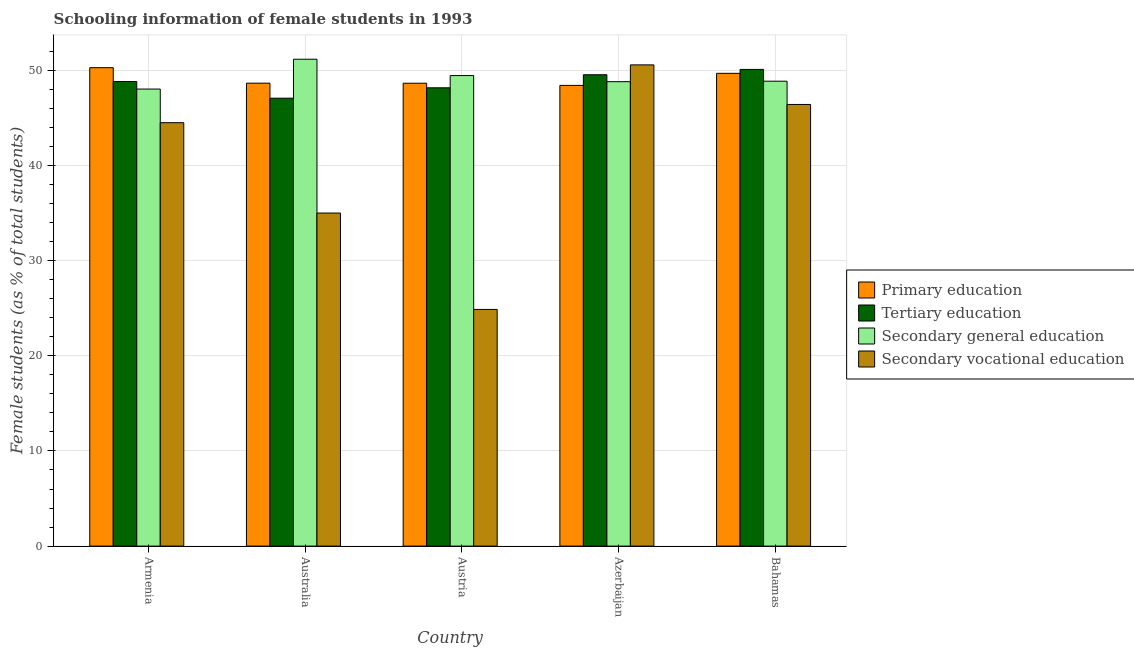How many different coloured bars are there?
Provide a short and direct response. 4. How many bars are there on the 1st tick from the left?
Provide a short and direct response. 4. What is the label of the 2nd group of bars from the left?
Provide a short and direct response. Australia. What is the percentage of female students in secondary education in Bahamas?
Keep it short and to the point. 48.86. Across all countries, what is the maximum percentage of female students in tertiary education?
Your answer should be compact. 50.09. Across all countries, what is the minimum percentage of female students in secondary vocational education?
Your answer should be very brief. 24.87. In which country was the percentage of female students in tertiary education maximum?
Your answer should be compact. Bahamas. In which country was the percentage of female students in tertiary education minimum?
Provide a succinct answer. Australia. What is the total percentage of female students in primary education in the graph?
Give a very brief answer. 245.66. What is the difference between the percentage of female students in secondary vocational education in Australia and that in Bahamas?
Make the answer very short. -11.41. What is the difference between the percentage of female students in primary education in Azerbaijan and the percentage of female students in secondary education in Armenia?
Keep it short and to the point. 0.39. What is the average percentage of female students in secondary vocational education per country?
Provide a succinct answer. 40.27. What is the difference between the percentage of female students in primary education and percentage of female students in tertiary education in Armenia?
Ensure brevity in your answer.  1.45. What is the ratio of the percentage of female students in secondary vocational education in Azerbaijan to that in Bahamas?
Offer a terse response. 1.09. Is the percentage of female students in secondary education in Armenia less than that in Azerbaijan?
Offer a very short reply. Yes. What is the difference between the highest and the second highest percentage of female students in tertiary education?
Your answer should be very brief. 0.56. What is the difference between the highest and the lowest percentage of female students in tertiary education?
Provide a short and direct response. 3.02. In how many countries, is the percentage of female students in secondary education greater than the average percentage of female students in secondary education taken over all countries?
Offer a terse response. 2. What does the 1st bar from the left in Armenia represents?
Provide a short and direct response. Primary education. What is the difference between two consecutive major ticks on the Y-axis?
Provide a short and direct response. 10. Does the graph contain any zero values?
Keep it short and to the point. No. Where does the legend appear in the graph?
Provide a succinct answer. Center right. How many legend labels are there?
Ensure brevity in your answer.  4. What is the title of the graph?
Your answer should be compact. Schooling information of female students in 1993. What is the label or title of the Y-axis?
Give a very brief answer. Female students (as % of total students). What is the Female students (as % of total students) in Primary education in Armenia?
Provide a succinct answer. 50.28. What is the Female students (as % of total students) of Tertiary education in Armenia?
Give a very brief answer. 48.82. What is the Female students (as % of total students) of Secondary general education in Armenia?
Make the answer very short. 48.03. What is the Female students (as % of total students) of Secondary vocational education in Armenia?
Your answer should be compact. 44.49. What is the Female students (as % of total students) in Primary education in Australia?
Provide a short and direct response. 48.65. What is the Female students (as % of total students) of Tertiary education in Australia?
Offer a very short reply. 47.07. What is the Female students (as % of total students) of Secondary general education in Australia?
Provide a short and direct response. 51.16. What is the Female students (as % of total students) of Secondary vocational education in Australia?
Ensure brevity in your answer.  35. What is the Female students (as % of total students) of Primary education in Austria?
Offer a terse response. 48.64. What is the Female students (as % of total students) of Tertiary education in Austria?
Give a very brief answer. 48.16. What is the Female students (as % of total students) of Secondary general education in Austria?
Provide a short and direct response. 49.45. What is the Female students (as % of total students) in Secondary vocational education in Austria?
Make the answer very short. 24.87. What is the Female students (as % of total students) in Primary education in Azerbaijan?
Give a very brief answer. 48.42. What is the Female students (as % of total students) in Tertiary education in Azerbaijan?
Provide a succinct answer. 49.53. What is the Female students (as % of total students) in Secondary general education in Azerbaijan?
Your response must be concise. 48.8. What is the Female students (as % of total students) in Secondary vocational education in Azerbaijan?
Make the answer very short. 50.57. What is the Female students (as % of total students) in Primary education in Bahamas?
Provide a succinct answer. 49.68. What is the Female students (as % of total students) of Tertiary education in Bahamas?
Provide a succinct answer. 50.09. What is the Female students (as % of total students) of Secondary general education in Bahamas?
Ensure brevity in your answer.  48.86. What is the Female students (as % of total students) in Secondary vocational education in Bahamas?
Ensure brevity in your answer.  46.41. Across all countries, what is the maximum Female students (as % of total students) in Primary education?
Keep it short and to the point. 50.28. Across all countries, what is the maximum Female students (as % of total students) of Tertiary education?
Keep it short and to the point. 50.09. Across all countries, what is the maximum Female students (as % of total students) in Secondary general education?
Your response must be concise. 51.16. Across all countries, what is the maximum Female students (as % of total students) of Secondary vocational education?
Ensure brevity in your answer.  50.57. Across all countries, what is the minimum Female students (as % of total students) in Primary education?
Provide a short and direct response. 48.42. Across all countries, what is the minimum Female students (as % of total students) in Tertiary education?
Your answer should be very brief. 47.07. Across all countries, what is the minimum Female students (as % of total students) of Secondary general education?
Keep it short and to the point. 48.03. Across all countries, what is the minimum Female students (as % of total students) in Secondary vocational education?
Ensure brevity in your answer.  24.87. What is the total Female students (as % of total students) of Primary education in the graph?
Ensure brevity in your answer.  245.66. What is the total Female students (as % of total students) of Tertiary education in the graph?
Offer a terse response. 243.68. What is the total Female students (as % of total students) of Secondary general education in the graph?
Ensure brevity in your answer.  246.3. What is the total Female students (as % of total students) in Secondary vocational education in the graph?
Offer a very short reply. 201.34. What is the difference between the Female students (as % of total students) in Primary education in Armenia and that in Australia?
Make the answer very short. 1.63. What is the difference between the Female students (as % of total students) in Tertiary education in Armenia and that in Australia?
Give a very brief answer. 1.75. What is the difference between the Female students (as % of total students) of Secondary general education in Armenia and that in Australia?
Give a very brief answer. -3.14. What is the difference between the Female students (as % of total students) in Secondary vocational education in Armenia and that in Australia?
Make the answer very short. 9.49. What is the difference between the Female students (as % of total students) of Primary education in Armenia and that in Austria?
Your answer should be compact. 1.63. What is the difference between the Female students (as % of total students) in Tertiary education in Armenia and that in Austria?
Ensure brevity in your answer.  0.66. What is the difference between the Female students (as % of total students) of Secondary general education in Armenia and that in Austria?
Provide a succinct answer. -1.42. What is the difference between the Female students (as % of total students) of Secondary vocational education in Armenia and that in Austria?
Your answer should be very brief. 19.62. What is the difference between the Female students (as % of total students) of Primary education in Armenia and that in Azerbaijan?
Ensure brevity in your answer.  1.86. What is the difference between the Female students (as % of total students) of Tertiary education in Armenia and that in Azerbaijan?
Provide a succinct answer. -0.71. What is the difference between the Female students (as % of total students) of Secondary general education in Armenia and that in Azerbaijan?
Keep it short and to the point. -0.78. What is the difference between the Female students (as % of total students) of Secondary vocational education in Armenia and that in Azerbaijan?
Offer a terse response. -6.08. What is the difference between the Female students (as % of total students) in Primary education in Armenia and that in Bahamas?
Your answer should be compact. 0.6. What is the difference between the Female students (as % of total students) in Tertiary education in Armenia and that in Bahamas?
Provide a short and direct response. -1.27. What is the difference between the Female students (as % of total students) of Secondary general education in Armenia and that in Bahamas?
Give a very brief answer. -0.83. What is the difference between the Female students (as % of total students) in Secondary vocational education in Armenia and that in Bahamas?
Your response must be concise. -1.92. What is the difference between the Female students (as % of total students) of Primary education in Australia and that in Austria?
Your response must be concise. 0.01. What is the difference between the Female students (as % of total students) in Tertiary education in Australia and that in Austria?
Give a very brief answer. -1.09. What is the difference between the Female students (as % of total students) of Secondary general education in Australia and that in Austria?
Give a very brief answer. 1.72. What is the difference between the Female students (as % of total students) in Secondary vocational education in Australia and that in Austria?
Make the answer very short. 10.13. What is the difference between the Female students (as % of total students) in Primary education in Australia and that in Azerbaijan?
Offer a very short reply. 0.23. What is the difference between the Female students (as % of total students) of Tertiary education in Australia and that in Azerbaijan?
Offer a very short reply. -2.46. What is the difference between the Female students (as % of total students) in Secondary general education in Australia and that in Azerbaijan?
Keep it short and to the point. 2.36. What is the difference between the Female students (as % of total students) in Secondary vocational education in Australia and that in Azerbaijan?
Offer a terse response. -15.57. What is the difference between the Female students (as % of total students) in Primary education in Australia and that in Bahamas?
Offer a terse response. -1.03. What is the difference between the Female students (as % of total students) in Tertiary education in Australia and that in Bahamas?
Make the answer very short. -3.02. What is the difference between the Female students (as % of total students) of Secondary general education in Australia and that in Bahamas?
Offer a terse response. 2.31. What is the difference between the Female students (as % of total students) of Secondary vocational education in Australia and that in Bahamas?
Offer a terse response. -11.41. What is the difference between the Female students (as % of total students) of Primary education in Austria and that in Azerbaijan?
Your answer should be very brief. 0.23. What is the difference between the Female students (as % of total students) in Tertiary education in Austria and that in Azerbaijan?
Keep it short and to the point. -1.37. What is the difference between the Female students (as % of total students) of Secondary general education in Austria and that in Azerbaijan?
Offer a very short reply. 0.64. What is the difference between the Female students (as % of total students) in Secondary vocational education in Austria and that in Azerbaijan?
Your response must be concise. -25.7. What is the difference between the Female students (as % of total students) in Primary education in Austria and that in Bahamas?
Keep it short and to the point. -1.04. What is the difference between the Female students (as % of total students) in Tertiary education in Austria and that in Bahamas?
Your answer should be compact. -1.93. What is the difference between the Female students (as % of total students) of Secondary general education in Austria and that in Bahamas?
Offer a very short reply. 0.59. What is the difference between the Female students (as % of total students) of Secondary vocational education in Austria and that in Bahamas?
Ensure brevity in your answer.  -21.54. What is the difference between the Female students (as % of total students) in Primary education in Azerbaijan and that in Bahamas?
Your response must be concise. -1.26. What is the difference between the Female students (as % of total students) of Tertiary education in Azerbaijan and that in Bahamas?
Provide a short and direct response. -0.56. What is the difference between the Female students (as % of total students) of Secondary general education in Azerbaijan and that in Bahamas?
Make the answer very short. -0.05. What is the difference between the Female students (as % of total students) in Secondary vocational education in Azerbaijan and that in Bahamas?
Offer a terse response. 4.16. What is the difference between the Female students (as % of total students) in Primary education in Armenia and the Female students (as % of total students) in Tertiary education in Australia?
Keep it short and to the point. 3.21. What is the difference between the Female students (as % of total students) of Primary education in Armenia and the Female students (as % of total students) of Secondary general education in Australia?
Offer a very short reply. -0.89. What is the difference between the Female students (as % of total students) in Primary education in Armenia and the Female students (as % of total students) in Secondary vocational education in Australia?
Provide a short and direct response. 15.28. What is the difference between the Female students (as % of total students) of Tertiary education in Armenia and the Female students (as % of total students) of Secondary general education in Australia?
Keep it short and to the point. -2.34. What is the difference between the Female students (as % of total students) in Tertiary education in Armenia and the Female students (as % of total students) in Secondary vocational education in Australia?
Your answer should be compact. 13.82. What is the difference between the Female students (as % of total students) in Secondary general education in Armenia and the Female students (as % of total students) in Secondary vocational education in Australia?
Your answer should be very brief. 13.03. What is the difference between the Female students (as % of total students) of Primary education in Armenia and the Female students (as % of total students) of Tertiary education in Austria?
Offer a terse response. 2.11. What is the difference between the Female students (as % of total students) of Primary education in Armenia and the Female students (as % of total students) of Secondary general education in Austria?
Your answer should be very brief. 0.83. What is the difference between the Female students (as % of total students) of Primary education in Armenia and the Female students (as % of total students) of Secondary vocational education in Austria?
Offer a very short reply. 25.4. What is the difference between the Female students (as % of total students) in Tertiary education in Armenia and the Female students (as % of total students) in Secondary general education in Austria?
Offer a very short reply. -0.63. What is the difference between the Female students (as % of total students) in Tertiary education in Armenia and the Female students (as % of total students) in Secondary vocational education in Austria?
Offer a terse response. 23.95. What is the difference between the Female students (as % of total students) in Secondary general education in Armenia and the Female students (as % of total students) in Secondary vocational education in Austria?
Provide a succinct answer. 23.16. What is the difference between the Female students (as % of total students) of Primary education in Armenia and the Female students (as % of total students) of Tertiary education in Azerbaijan?
Ensure brevity in your answer.  0.74. What is the difference between the Female students (as % of total students) of Primary education in Armenia and the Female students (as % of total students) of Secondary general education in Azerbaijan?
Make the answer very short. 1.47. What is the difference between the Female students (as % of total students) in Primary education in Armenia and the Female students (as % of total students) in Secondary vocational education in Azerbaijan?
Provide a succinct answer. -0.29. What is the difference between the Female students (as % of total students) in Tertiary education in Armenia and the Female students (as % of total students) in Secondary general education in Azerbaijan?
Provide a succinct answer. 0.02. What is the difference between the Female students (as % of total students) in Tertiary education in Armenia and the Female students (as % of total students) in Secondary vocational education in Azerbaijan?
Provide a short and direct response. -1.75. What is the difference between the Female students (as % of total students) of Secondary general education in Armenia and the Female students (as % of total students) of Secondary vocational education in Azerbaijan?
Provide a short and direct response. -2.54. What is the difference between the Female students (as % of total students) of Primary education in Armenia and the Female students (as % of total students) of Tertiary education in Bahamas?
Keep it short and to the point. 0.18. What is the difference between the Female students (as % of total students) of Primary education in Armenia and the Female students (as % of total students) of Secondary general education in Bahamas?
Offer a terse response. 1.42. What is the difference between the Female students (as % of total students) in Primary education in Armenia and the Female students (as % of total students) in Secondary vocational education in Bahamas?
Your response must be concise. 3.87. What is the difference between the Female students (as % of total students) in Tertiary education in Armenia and the Female students (as % of total students) in Secondary general education in Bahamas?
Your answer should be very brief. -0.03. What is the difference between the Female students (as % of total students) of Tertiary education in Armenia and the Female students (as % of total students) of Secondary vocational education in Bahamas?
Your response must be concise. 2.41. What is the difference between the Female students (as % of total students) of Secondary general education in Armenia and the Female students (as % of total students) of Secondary vocational education in Bahamas?
Your answer should be very brief. 1.62. What is the difference between the Female students (as % of total students) of Primary education in Australia and the Female students (as % of total students) of Tertiary education in Austria?
Provide a succinct answer. 0.49. What is the difference between the Female students (as % of total students) in Primary education in Australia and the Female students (as % of total students) in Secondary general education in Austria?
Your answer should be compact. -0.8. What is the difference between the Female students (as % of total students) in Primary education in Australia and the Female students (as % of total students) in Secondary vocational education in Austria?
Ensure brevity in your answer.  23.78. What is the difference between the Female students (as % of total students) in Tertiary education in Australia and the Female students (as % of total students) in Secondary general education in Austria?
Offer a very short reply. -2.38. What is the difference between the Female students (as % of total students) of Tertiary education in Australia and the Female students (as % of total students) of Secondary vocational education in Austria?
Offer a very short reply. 22.2. What is the difference between the Female students (as % of total students) of Secondary general education in Australia and the Female students (as % of total students) of Secondary vocational education in Austria?
Keep it short and to the point. 26.29. What is the difference between the Female students (as % of total students) of Primary education in Australia and the Female students (as % of total students) of Tertiary education in Azerbaijan?
Your response must be concise. -0.89. What is the difference between the Female students (as % of total students) in Primary education in Australia and the Female students (as % of total students) in Secondary general education in Azerbaijan?
Your answer should be compact. -0.16. What is the difference between the Female students (as % of total students) of Primary education in Australia and the Female students (as % of total students) of Secondary vocational education in Azerbaijan?
Make the answer very short. -1.92. What is the difference between the Female students (as % of total students) of Tertiary education in Australia and the Female students (as % of total students) of Secondary general education in Azerbaijan?
Ensure brevity in your answer.  -1.73. What is the difference between the Female students (as % of total students) in Tertiary education in Australia and the Female students (as % of total students) in Secondary vocational education in Azerbaijan?
Keep it short and to the point. -3.5. What is the difference between the Female students (as % of total students) in Secondary general education in Australia and the Female students (as % of total students) in Secondary vocational education in Azerbaijan?
Keep it short and to the point. 0.6. What is the difference between the Female students (as % of total students) in Primary education in Australia and the Female students (as % of total students) in Tertiary education in Bahamas?
Your answer should be compact. -1.44. What is the difference between the Female students (as % of total students) of Primary education in Australia and the Female students (as % of total students) of Secondary general education in Bahamas?
Your response must be concise. -0.21. What is the difference between the Female students (as % of total students) in Primary education in Australia and the Female students (as % of total students) in Secondary vocational education in Bahamas?
Ensure brevity in your answer.  2.24. What is the difference between the Female students (as % of total students) in Tertiary education in Australia and the Female students (as % of total students) in Secondary general education in Bahamas?
Your response must be concise. -1.79. What is the difference between the Female students (as % of total students) in Tertiary education in Australia and the Female students (as % of total students) in Secondary vocational education in Bahamas?
Your answer should be very brief. 0.66. What is the difference between the Female students (as % of total students) of Secondary general education in Australia and the Female students (as % of total students) of Secondary vocational education in Bahamas?
Offer a terse response. 4.76. What is the difference between the Female students (as % of total students) in Primary education in Austria and the Female students (as % of total students) in Tertiary education in Azerbaijan?
Your answer should be very brief. -0.89. What is the difference between the Female students (as % of total students) in Primary education in Austria and the Female students (as % of total students) in Secondary general education in Azerbaijan?
Your answer should be very brief. -0.16. What is the difference between the Female students (as % of total students) of Primary education in Austria and the Female students (as % of total students) of Secondary vocational education in Azerbaijan?
Ensure brevity in your answer.  -1.93. What is the difference between the Female students (as % of total students) of Tertiary education in Austria and the Female students (as % of total students) of Secondary general education in Azerbaijan?
Make the answer very short. -0.64. What is the difference between the Female students (as % of total students) in Tertiary education in Austria and the Female students (as % of total students) in Secondary vocational education in Azerbaijan?
Your answer should be compact. -2.41. What is the difference between the Female students (as % of total students) of Secondary general education in Austria and the Female students (as % of total students) of Secondary vocational education in Azerbaijan?
Keep it short and to the point. -1.12. What is the difference between the Female students (as % of total students) of Primary education in Austria and the Female students (as % of total students) of Tertiary education in Bahamas?
Your response must be concise. -1.45. What is the difference between the Female students (as % of total students) of Primary education in Austria and the Female students (as % of total students) of Secondary general education in Bahamas?
Offer a very short reply. -0.21. What is the difference between the Female students (as % of total students) of Primary education in Austria and the Female students (as % of total students) of Secondary vocational education in Bahamas?
Make the answer very short. 2.23. What is the difference between the Female students (as % of total students) of Tertiary education in Austria and the Female students (as % of total students) of Secondary general education in Bahamas?
Ensure brevity in your answer.  -0.69. What is the difference between the Female students (as % of total students) in Tertiary education in Austria and the Female students (as % of total students) in Secondary vocational education in Bahamas?
Provide a short and direct response. 1.75. What is the difference between the Female students (as % of total students) of Secondary general education in Austria and the Female students (as % of total students) of Secondary vocational education in Bahamas?
Ensure brevity in your answer.  3.04. What is the difference between the Female students (as % of total students) of Primary education in Azerbaijan and the Female students (as % of total students) of Tertiary education in Bahamas?
Give a very brief answer. -1.68. What is the difference between the Female students (as % of total students) of Primary education in Azerbaijan and the Female students (as % of total students) of Secondary general education in Bahamas?
Make the answer very short. -0.44. What is the difference between the Female students (as % of total students) of Primary education in Azerbaijan and the Female students (as % of total students) of Secondary vocational education in Bahamas?
Give a very brief answer. 2.01. What is the difference between the Female students (as % of total students) of Tertiary education in Azerbaijan and the Female students (as % of total students) of Secondary general education in Bahamas?
Your response must be concise. 0.68. What is the difference between the Female students (as % of total students) in Tertiary education in Azerbaijan and the Female students (as % of total students) in Secondary vocational education in Bahamas?
Give a very brief answer. 3.12. What is the difference between the Female students (as % of total students) in Secondary general education in Azerbaijan and the Female students (as % of total students) in Secondary vocational education in Bahamas?
Your answer should be compact. 2.39. What is the average Female students (as % of total students) in Primary education per country?
Your answer should be compact. 49.13. What is the average Female students (as % of total students) in Tertiary education per country?
Your response must be concise. 48.74. What is the average Female students (as % of total students) in Secondary general education per country?
Your response must be concise. 49.26. What is the average Female students (as % of total students) in Secondary vocational education per country?
Your answer should be very brief. 40.27. What is the difference between the Female students (as % of total students) in Primary education and Female students (as % of total students) in Tertiary education in Armenia?
Your answer should be compact. 1.45. What is the difference between the Female students (as % of total students) in Primary education and Female students (as % of total students) in Secondary general education in Armenia?
Keep it short and to the point. 2.25. What is the difference between the Female students (as % of total students) of Primary education and Female students (as % of total students) of Secondary vocational education in Armenia?
Your response must be concise. 5.78. What is the difference between the Female students (as % of total students) in Tertiary education and Female students (as % of total students) in Secondary general education in Armenia?
Provide a short and direct response. 0.79. What is the difference between the Female students (as % of total students) of Tertiary education and Female students (as % of total students) of Secondary vocational education in Armenia?
Your answer should be compact. 4.33. What is the difference between the Female students (as % of total students) in Secondary general education and Female students (as % of total students) in Secondary vocational education in Armenia?
Offer a terse response. 3.54. What is the difference between the Female students (as % of total students) in Primary education and Female students (as % of total students) in Tertiary education in Australia?
Offer a terse response. 1.58. What is the difference between the Female students (as % of total students) of Primary education and Female students (as % of total students) of Secondary general education in Australia?
Your response must be concise. -2.52. What is the difference between the Female students (as % of total students) of Primary education and Female students (as % of total students) of Secondary vocational education in Australia?
Your response must be concise. 13.65. What is the difference between the Female students (as % of total students) in Tertiary education and Female students (as % of total students) in Secondary general education in Australia?
Make the answer very short. -4.1. What is the difference between the Female students (as % of total students) of Tertiary education and Female students (as % of total students) of Secondary vocational education in Australia?
Your answer should be compact. 12.07. What is the difference between the Female students (as % of total students) in Secondary general education and Female students (as % of total students) in Secondary vocational education in Australia?
Your answer should be compact. 16.16. What is the difference between the Female students (as % of total students) of Primary education and Female students (as % of total students) of Tertiary education in Austria?
Give a very brief answer. 0.48. What is the difference between the Female students (as % of total students) in Primary education and Female students (as % of total students) in Secondary general education in Austria?
Your answer should be compact. -0.81. What is the difference between the Female students (as % of total students) of Primary education and Female students (as % of total students) of Secondary vocational education in Austria?
Provide a succinct answer. 23.77. What is the difference between the Female students (as % of total students) in Tertiary education and Female students (as % of total students) in Secondary general education in Austria?
Your response must be concise. -1.29. What is the difference between the Female students (as % of total students) in Tertiary education and Female students (as % of total students) in Secondary vocational education in Austria?
Provide a succinct answer. 23.29. What is the difference between the Female students (as % of total students) of Secondary general education and Female students (as % of total students) of Secondary vocational education in Austria?
Ensure brevity in your answer.  24.58. What is the difference between the Female students (as % of total students) of Primary education and Female students (as % of total students) of Tertiary education in Azerbaijan?
Provide a short and direct response. -1.12. What is the difference between the Female students (as % of total students) in Primary education and Female students (as % of total students) in Secondary general education in Azerbaijan?
Offer a terse response. -0.39. What is the difference between the Female students (as % of total students) in Primary education and Female students (as % of total students) in Secondary vocational education in Azerbaijan?
Make the answer very short. -2.15. What is the difference between the Female students (as % of total students) in Tertiary education and Female students (as % of total students) in Secondary general education in Azerbaijan?
Make the answer very short. 0.73. What is the difference between the Female students (as % of total students) of Tertiary education and Female students (as % of total students) of Secondary vocational education in Azerbaijan?
Ensure brevity in your answer.  -1.04. What is the difference between the Female students (as % of total students) of Secondary general education and Female students (as % of total students) of Secondary vocational education in Azerbaijan?
Keep it short and to the point. -1.77. What is the difference between the Female students (as % of total students) of Primary education and Female students (as % of total students) of Tertiary education in Bahamas?
Keep it short and to the point. -0.41. What is the difference between the Female students (as % of total students) of Primary education and Female students (as % of total students) of Secondary general education in Bahamas?
Your answer should be compact. 0.82. What is the difference between the Female students (as % of total students) in Primary education and Female students (as % of total students) in Secondary vocational education in Bahamas?
Keep it short and to the point. 3.27. What is the difference between the Female students (as % of total students) of Tertiary education and Female students (as % of total students) of Secondary general education in Bahamas?
Make the answer very short. 1.24. What is the difference between the Female students (as % of total students) of Tertiary education and Female students (as % of total students) of Secondary vocational education in Bahamas?
Ensure brevity in your answer.  3.68. What is the difference between the Female students (as % of total students) of Secondary general education and Female students (as % of total students) of Secondary vocational education in Bahamas?
Ensure brevity in your answer.  2.45. What is the ratio of the Female students (as % of total students) of Primary education in Armenia to that in Australia?
Give a very brief answer. 1.03. What is the ratio of the Female students (as % of total students) of Tertiary education in Armenia to that in Australia?
Your answer should be very brief. 1.04. What is the ratio of the Female students (as % of total students) of Secondary general education in Armenia to that in Australia?
Provide a succinct answer. 0.94. What is the ratio of the Female students (as % of total students) of Secondary vocational education in Armenia to that in Australia?
Your response must be concise. 1.27. What is the ratio of the Female students (as % of total students) of Primary education in Armenia to that in Austria?
Your answer should be very brief. 1.03. What is the ratio of the Female students (as % of total students) of Tertiary education in Armenia to that in Austria?
Offer a terse response. 1.01. What is the ratio of the Female students (as % of total students) of Secondary general education in Armenia to that in Austria?
Your answer should be compact. 0.97. What is the ratio of the Female students (as % of total students) of Secondary vocational education in Armenia to that in Austria?
Provide a short and direct response. 1.79. What is the ratio of the Female students (as % of total students) of Primary education in Armenia to that in Azerbaijan?
Give a very brief answer. 1.04. What is the ratio of the Female students (as % of total students) of Tertiary education in Armenia to that in Azerbaijan?
Your response must be concise. 0.99. What is the ratio of the Female students (as % of total students) in Secondary general education in Armenia to that in Azerbaijan?
Your answer should be very brief. 0.98. What is the ratio of the Female students (as % of total students) in Secondary vocational education in Armenia to that in Azerbaijan?
Your response must be concise. 0.88. What is the ratio of the Female students (as % of total students) of Tertiary education in Armenia to that in Bahamas?
Offer a terse response. 0.97. What is the ratio of the Female students (as % of total students) in Secondary general education in Armenia to that in Bahamas?
Make the answer very short. 0.98. What is the ratio of the Female students (as % of total students) of Secondary vocational education in Armenia to that in Bahamas?
Provide a short and direct response. 0.96. What is the ratio of the Female students (as % of total students) of Tertiary education in Australia to that in Austria?
Give a very brief answer. 0.98. What is the ratio of the Female students (as % of total students) of Secondary general education in Australia to that in Austria?
Provide a short and direct response. 1.03. What is the ratio of the Female students (as % of total students) in Secondary vocational education in Australia to that in Austria?
Provide a succinct answer. 1.41. What is the ratio of the Female students (as % of total students) of Tertiary education in Australia to that in Azerbaijan?
Provide a short and direct response. 0.95. What is the ratio of the Female students (as % of total students) in Secondary general education in Australia to that in Azerbaijan?
Give a very brief answer. 1.05. What is the ratio of the Female students (as % of total students) in Secondary vocational education in Australia to that in Azerbaijan?
Make the answer very short. 0.69. What is the ratio of the Female students (as % of total students) in Primary education in Australia to that in Bahamas?
Make the answer very short. 0.98. What is the ratio of the Female students (as % of total students) of Tertiary education in Australia to that in Bahamas?
Give a very brief answer. 0.94. What is the ratio of the Female students (as % of total students) of Secondary general education in Australia to that in Bahamas?
Provide a succinct answer. 1.05. What is the ratio of the Female students (as % of total students) in Secondary vocational education in Australia to that in Bahamas?
Offer a terse response. 0.75. What is the ratio of the Female students (as % of total students) of Primary education in Austria to that in Azerbaijan?
Your response must be concise. 1. What is the ratio of the Female students (as % of total students) in Tertiary education in Austria to that in Azerbaijan?
Your answer should be very brief. 0.97. What is the ratio of the Female students (as % of total students) in Secondary general education in Austria to that in Azerbaijan?
Keep it short and to the point. 1.01. What is the ratio of the Female students (as % of total students) of Secondary vocational education in Austria to that in Azerbaijan?
Give a very brief answer. 0.49. What is the ratio of the Female students (as % of total students) of Primary education in Austria to that in Bahamas?
Your answer should be very brief. 0.98. What is the ratio of the Female students (as % of total students) in Tertiary education in Austria to that in Bahamas?
Your answer should be very brief. 0.96. What is the ratio of the Female students (as % of total students) in Secondary general education in Austria to that in Bahamas?
Make the answer very short. 1.01. What is the ratio of the Female students (as % of total students) of Secondary vocational education in Austria to that in Bahamas?
Provide a succinct answer. 0.54. What is the ratio of the Female students (as % of total students) of Primary education in Azerbaijan to that in Bahamas?
Ensure brevity in your answer.  0.97. What is the ratio of the Female students (as % of total students) of Secondary vocational education in Azerbaijan to that in Bahamas?
Offer a very short reply. 1.09. What is the difference between the highest and the second highest Female students (as % of total students) of Primary education?
Ensure brevity in your answer.  0.6. What is the difference between the highest and the second highest Female students (as % of total students) in Tertiary education?
Offer a very short reply. 0.56. What is the difference between the highest and the second highest Female students (as % of total students) in Secondary general education?
Keep it short and to the point. 1.72. What is the difference between the highest and the second highest Female students (as % of total students) in Secondary vocational education?
Keep it short and to the point. 4.16. What is the difference between the highest and the lowest Female students (as % of total students) of Primary education?
Make the answer very short. 1.86. What is the difference between the highest and the lowest Female students (as % of total students) in Tertiary education?
Give a very brief answer. 3.02. What is the difference between the highest and the lowest Female students (as % of total students) of Secondary general education?
Ensure brevity in your answer.  3.14. What is the difference between the highest and the lowest Female students (as % of total students) of Secondary vocational education?
Make the answer very short. 25.7. 